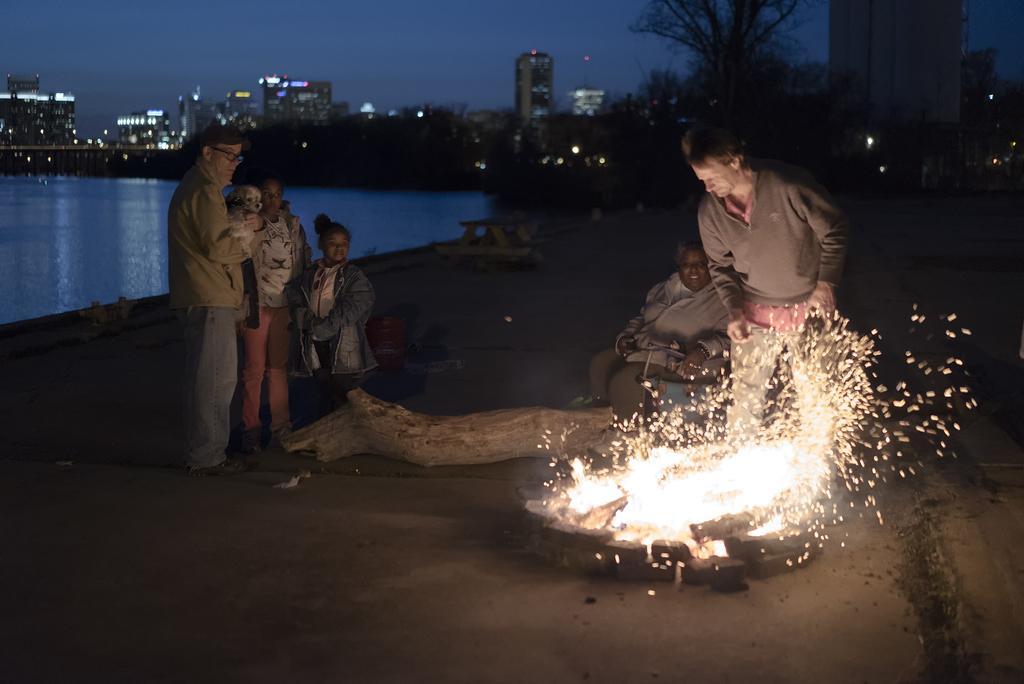Can you describe this image briefly? There are people and we can see fire, wooden object and water. In the background of the image we can see trees, buildings, lights and sky. 